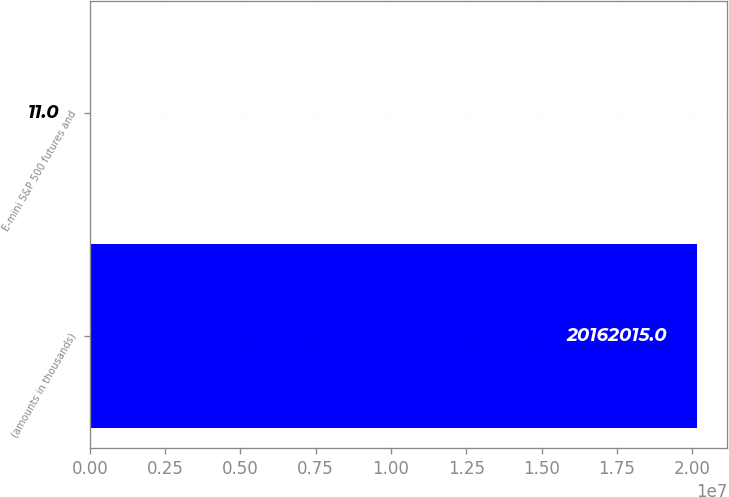<chart> <loc_0><loc_0><loc_500><loc_500><bar_chart><fcel>(amounts in thousands)<fcel>E-mini S&P 500 futures and<nl><fcel>2.0162e+07<fcel>11<nl></chart> 